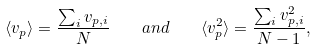<formula> <loc_0><loc_0><loc_500><loc_500>\langle v _ { p } \rangle = \frac { \sum _ { i } v _ { p , i } } { N } \quad a n d \quad \langle v _ { p } ^ { 2 } \rangle = \frac { \sum _ { i } v ^ { 2 } _ { p , i } } { N - 1 } ,</formula> 